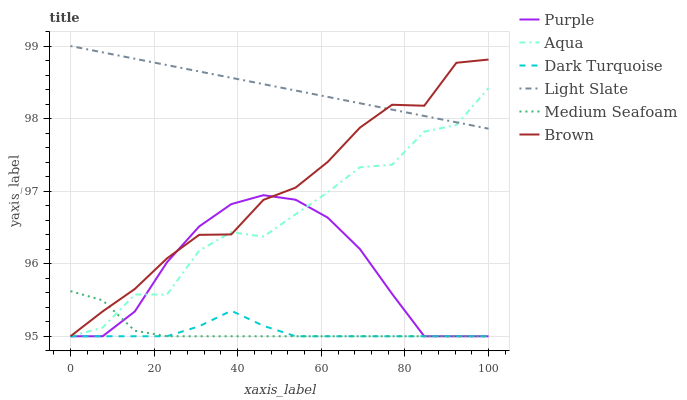Does Dark Turquoise have the minimum area under the curve?
Answer yes or no. Yes. Does Light Slate have the maximum area under the curve?
Answer yes or no. Yes. Does Purple have the minimum area under the curve?
Answer yes or no. No. Does Purple have the maximum area under the curve?
Answer yes or no. No. Is Light Slate the smoothest?
Answer yes or no. Yes. Is Aqua the roughest?
Answer yes or no. Yes. Is Purple the smoothest?
Answer yes or no. No. Is Purple the roughest?
Answer yes or no. No. Does Brown have the lowest value?
Answer yes or no. Yes. Does Light Slate have the lowest value?
Answer yes or no. No. Does Light Slate have the highest value?
Answer yes or no. Yes. Does Purple have the highest value?
Answer yes or no. No. Is Purple less than Light Slate?
Answer yes or no. Yes. Is Light Slate greater than Dark Turquoise?
Answer yes or no. Yes. Does Medium Seafoam intersect Brown?
Answer yes or no. Yes. Is Medium Seafoam less than Brown?
Answer yes or no. No. Is Medium Seafoam greater than Brown?
Answer yes or no. No. Does Purple intersect Light Slate?
Answer yes or no. No. 